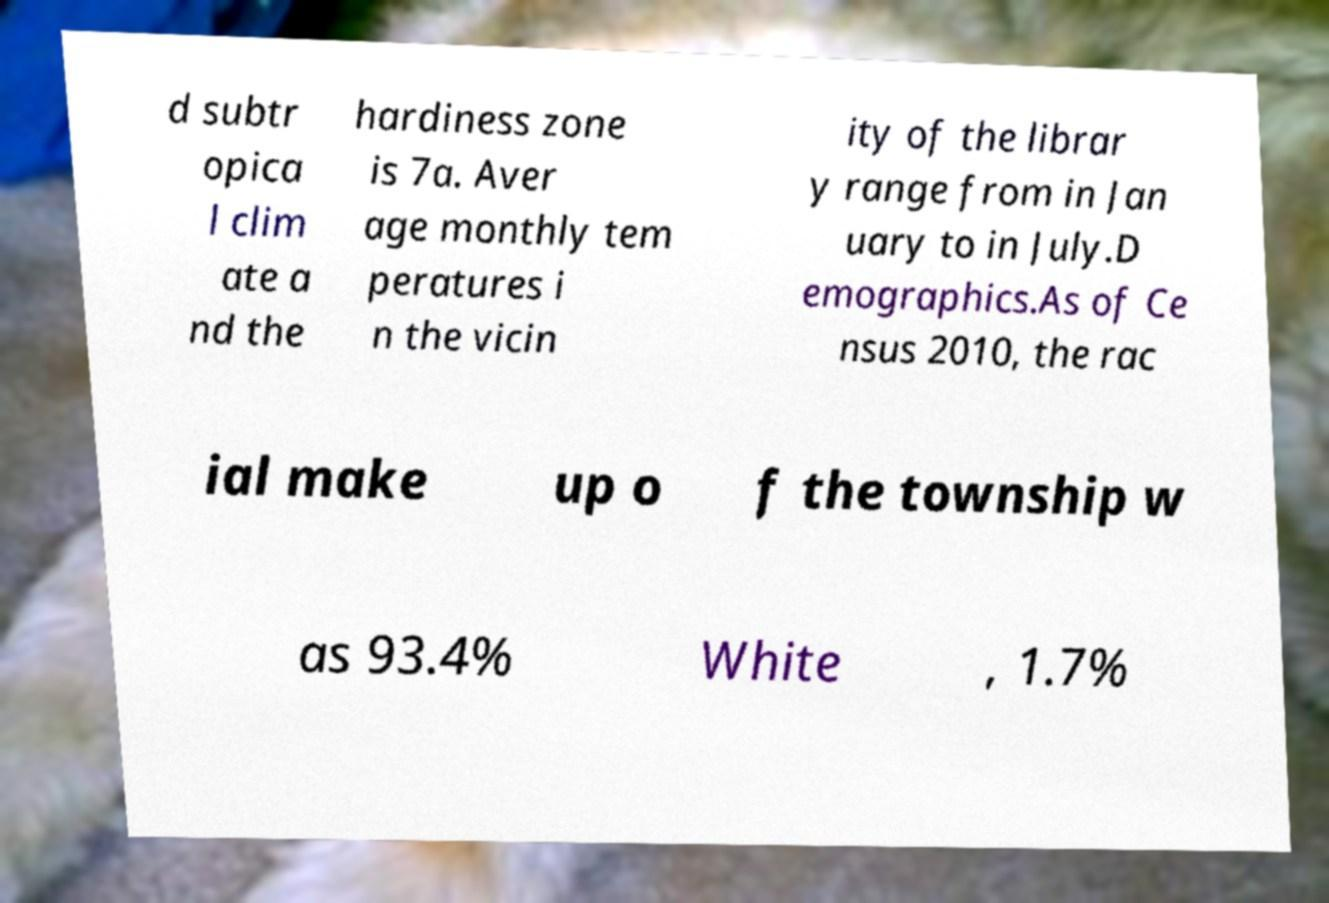Please read and relay the text visible in this image. What does it say? d subtr opica l clim ate a nd the hardiness zone is 7a. Aver age monthly tem peratures i n the vicin ity of the librar y range from in Jan uary to in July.D emographics.As of Ce nsus 2010, the rac ial make up o f the township w as 93.4% White , 1.7% 